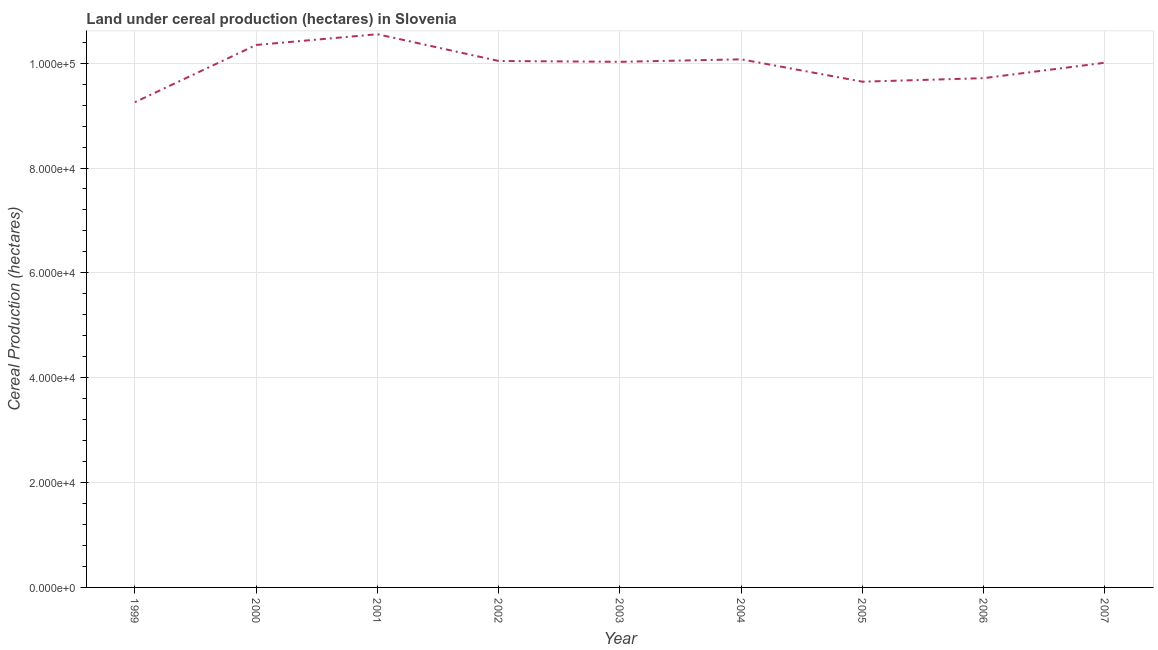What is the land under cereal production in 2005?
Offer a very short reply. 9.65e+04. Across all years, what is the maximum land under cereal production?
Provide a short and direct response. 1.06e+05. Across all years, what is the minimum land under cereal production?
Your response must be concise. 9.25e+04. In which year was the land under cereal production minimum?
Ensure brevity in your answer.  1999. What is the sum of the land under cereal production?
Offer a very short reply. 8.97e+05. What is the difference between the land under cereal production in 2004 and 2006?
Make the answer very short. 3592. What is the average land under cereal production per year?
Offer a terse response. 9.96e+04. What is the median land under cereal production?
Offer a very short reply. 1.00e+05. Do a majority of the years between 2006 and 1999 (inclusive) have land under cereal production greater than 64000 hectares?
Your answer should be very brief. Yes. What is the ratio of the land under cereal production in 1999 to that in 2002?
Keep it short and to the point. 0.92. Is the difference between the land under cereal production in 2001 and 2003 greater than the difference between any two years?
Keep it short and to the point. No. What is the difference between the highest and the second highest land under cereal production?
Provide a succinct answer. 2048. Is the sum of the land under cereal production in 2000 and 2002 greater than the maximum land under cereal production across all years?
Offer a terse response. Yes. What is the difference between the highest and the lowest land under cereal production?
Keep it short and to the point. 1.30e+04. In how many years, is the land under cereal production greater than the average land under cereal production taken over all years?
Keep it short and to the point. 6. Does the land under cereal production monotonically increase over the years?
Provide a succinct answer. No. How many years are there in the graph?
Provide a succinct answer. 9. What is the difference between two consecutive major ticks on the Y-axis?
Ensure brevity in your answer.  2.00e+04. Are the values on the major ticks of Y-axis written in scientific E-notation?
Offer a very short reply. Yes. Does the graph contain any zero values?
Your answer should be very brief. No. Does the graph contain grids?
Ensure brevity in your answer.  Yes. What is the title of the graph?
Your response must be concise. Land under cereal production (hectares) in Slovenia. What is the label or title of the Y-axis?
Provide a succinct answer. Cereal Production (hectares). What is the Cereal Production (hectares) in 1999?
Provide a succinct answer. 9.25e+04. What is the Cereal Production (hectares) of 2000?
Keep it short and to the point. 1.03e+05. What is the Cereal Production (hectares) in 2001?
Your answer should be compact. 1.06e+05. What is the Cereal Production (hectares) in 2002?
Provide a short and direct response. 1.00e+05. What is the Cereal Production (hectares) in 2003?
Provide a short and direct response. 1.00e+05. What is the Cereal Production (hectares) of 2004?
Your answer should be compact. 1.01e+05. What is the Cereal Production (hectares) in 2005?
Offer a terse response. 9.65e+04. What is the Cereal Production (hectares) of 2006?
Provide a short and direct response. 9.71e+04. What is the Cereal Production (hectares) in 2007?
Keep it short and to the point. 1.00e+05. What is the difference between the Cereal Production (hectares) in 1999 and 2000?
Your answer should be very brief. -1.09e+04. What is the difference between the Cereal Production (hectares) in 1999 and 2001?
Your response must be concise. -1.30e+04. What is the difference between the Cereal Production (hectares) in 1999 and 2002?
Your answer should be very brief. -7865. What is the difference between the Cereal Production (hectares) in 1999 and 2003?
Offer a terse response. -7706. What is the difference between the Cereal Production (hectares) in 1999 and 2004?
Provide a short and direct response. -8180. What is the difference between the Cereal Production (hectares) in 1999 and 2005?
Provide a short and direct response. -3912. What is the difference between the Cereal Production (hectares) in 1999 and 2006?
Your answer should be very brief. -4588. What is the difference between the Cereal Production (hectares) in 1999 and 2007?
Give a very brief answer. -7534. What is the difference between the Cereal Production (hectares) in 2000 and 2001?
Offer a very short reply. -2048. What is the difference between the Cereal Production (hectares) in 2000 and 2002?
Ensure brevity in your answer.  3054. What is the difference between the Cereal Production (hectares) in 2000 and 2003?
Provide a succinct answer. 3213. What is the difference between the Cereal Production (hectares) in 2000 and 2004?
Offer a very short reply. 2739. What is the difference between the Cereal Production (hectares) in 2000 and 2005?
Offer a very short reply. 7007. What is the difference between the Cereal Production (hectares) in 2000 and 2006?
Your answer should be compact. 6331. What is the difference between the Cereal Production (hectares) in 2000 and 2007?
Your answer should be compact. 3385. What is the difference between the Cereal Production (hectares) in 2001 and 2002?
Keep it short and to the point. 5102. What is the difference between the Cereal Production (hectares) in 2001 and 2003?
Make the answer very short. 5261. What is the difference between the Cereal Production (hectares) in 2001 and 2004?
Your answer should be very brief. 4787. What is the difference between the Cereal Production (hectares) in 2001 and 2005?
Give a very brief answer. 9055. What is the difference between the Cereal Production (hectares) in 2001 and 2006?
Your response must be concise. 8379. What is the difference between the Cereal Production (hectares) in 2001 and 2007?
Make the answer very short. 5433. What is the difference between the Cereal Production (hectares) in 2002 and 2003?
Provide a succinct answer. 159. What is the difference between the Cereal Production (hectares) in 2002 and 2004?
Give a very brief answer. -315. What is the difference between the Cereal Production (hectares) in 2002 and 2005?
Make the answer very short. 3953. What is the difference between the Cereal Production (hectares) in 2002 and 2006?
Make the answer very short. 3277. What is the difference between the Cereal Production (hectares) in 2002 and 2007?
Your response must be concise. 331. What is the difference between the Cereal Production (hectares) in 2003 and 2004?
Your answer should be very brief. -474. What is the difference between the Cereal Production (hectares) in 2003 and 2005?
Make the answer very short. 3794. What is the difference between the Cereal Production (hectares) in 2003 and 2006?
Keep it short and to the point. 3118. What is the difference between the Cereal Production (hectares) in 2003 and 2007?
Offer a terse response. 172. What is the difference between the Cereal Production (hectares) in 2004 and 2005?
Your answer should be compact. 4268. What is the difference between the Cereal Production (hectares) in 2004 and 2006?
Offer a very short reply. 3592. What is the difference between the Cereal Production (hectares) in 2004 and 2007?
Provide a succinct answer. 646. What is the difference between the Cereal Production (hectares) in 2005 and 2006?
Offer a very short reply. -676. What is the difference between the Cereal Production (hectares) in 2005 and 2007?
Keep it short and to the point. -3622. What is the difference between the Cereal Production (hectares) in 2006 and 2007?
Provide a succinct answer. -2946. What is the ratio of the Cereal Production (hectares) in 1999 to that in 2000?
Your answer should be compact. 0.89. What is the ratio of the Cereal Production (hectares) in 1999 to that in 2001?
Offer a terse response. 0.88. What is the ratio of the Cereal Production (hectares) in 1999 to that in 2002?
Your answer should be very brief. 0.92. What is the ratio of the Cereal Production (hectares) in 1999 to that in 2003?
Ensure brevity in your answer.  0.92. What is the ratio of the Cereal Production (hectares) in 1999 to that in 2004?
Offer a terse response. 0.92. What is the ratio of the Cereal Production (hectares) in 1999 to that in 2006?
Your answer should be compact. 0.95. What is the ratio of the Cereal Production (hectares) in 1999 to that in 2007?
Offer a very short reply. 0.93. What is the ratio of the Cereal Production (hectares) in 2000 to that in 2001?
Keep it short and to the point. 0.98. What is the ratio of the Cereal Production (hectares) in 2000 to that in 2002?
Provide a succinct answer. 1.03. What is the ratio of the Cereal Production (hectares) in 2000 to that in 2003?
Offer a very short reply. 1.03. What is the ratio of the Cereal Production (hectares) in 2000 to that in 2004?
Offer a very short reply. 1.03. What is the ratio of the Cereal Production (hectares) in 2000 to that in 2005?
Offer a very short reply. 1.07. What is the ratio of the Cereal Production (hectares) in 2000 to that in 2006?
Provide a succinct answer. 1.06. What is the ratio of the Cereal Production (hectares) in 2000 to that in 2007?
Provide a short and direct response. 1.03. What is the ratio of the Cereal Production (hectares) in 2001 to that in 2002?
Keep it short and to the point. 1.05. What is the ratio of the Cereal Production (hectares) in 2001 to that in 2003?
Your answer should be very brief. 1.05. What is the ratio of the Cereal Production (hectares) in 2001 to that in 2004?
Make the answer very short. 1.05. What is the ratio of the Cereal Production (hectares) in 2001 to that in 2005?
Provide a succinct answer. 1.09. What is the ratio of the Cereal Production (hectares) in 2001 to that in 2006?
Make the answer very short. 1.09. What is the ratio of the Cereal Production (hectares) in 2001 to that in 2007?
Provide a succinct answer. 1.05. What is the ratio of the Cereal Production (hectares) in 2002 to that in 2003?
Provide a short and direct response. 1. What is the ratio of the Cereal Production (hectares) in 2002 to that in 2004?
Ensure brevity in your answer.  1. What is the ratio of the Cereal Production (hectares) in 2002 to that in 2005?
Offer a terse response. 1.04. What is the ratio of the Cereal Production (hectares) in 2002 to that in 2006?
Provide a short and direct response. 1.03. What is the ratio of the Cereal Production (hectares) in 2002 to that in 2007?
Your response must be concise. 1. What is the ratio of the Cereal Production (hectares) in 2003 to that in 2005?
Offer a very short reply. 1.04. What is the ratio of the Cereal Production (hectares) in 2003 to that in 2006?
Provide a short and direct response. 1.03. What is the ratio of the Cereal Production (hectares) in 2004 to that in 2005?
Your answer should be very brief. 1.04. What is the ratio of the Cereal Production (hectares) in 2004 to that in 2006?
Ensure brevity in your answer.  1.04. What is the ratio of the Cereal Production (hectares) in 2004 to that in 2007?
Your answer should be very brief. 1.01. What is the ratio of the Cereal Production (hectares) in 2005 to that in 2007?
Your response must be concise. 0.96. What is the ratio of the Cereal Production (hectares) in 2006 to that in 2007?
Ensure brevity in your answer.  0.97. 